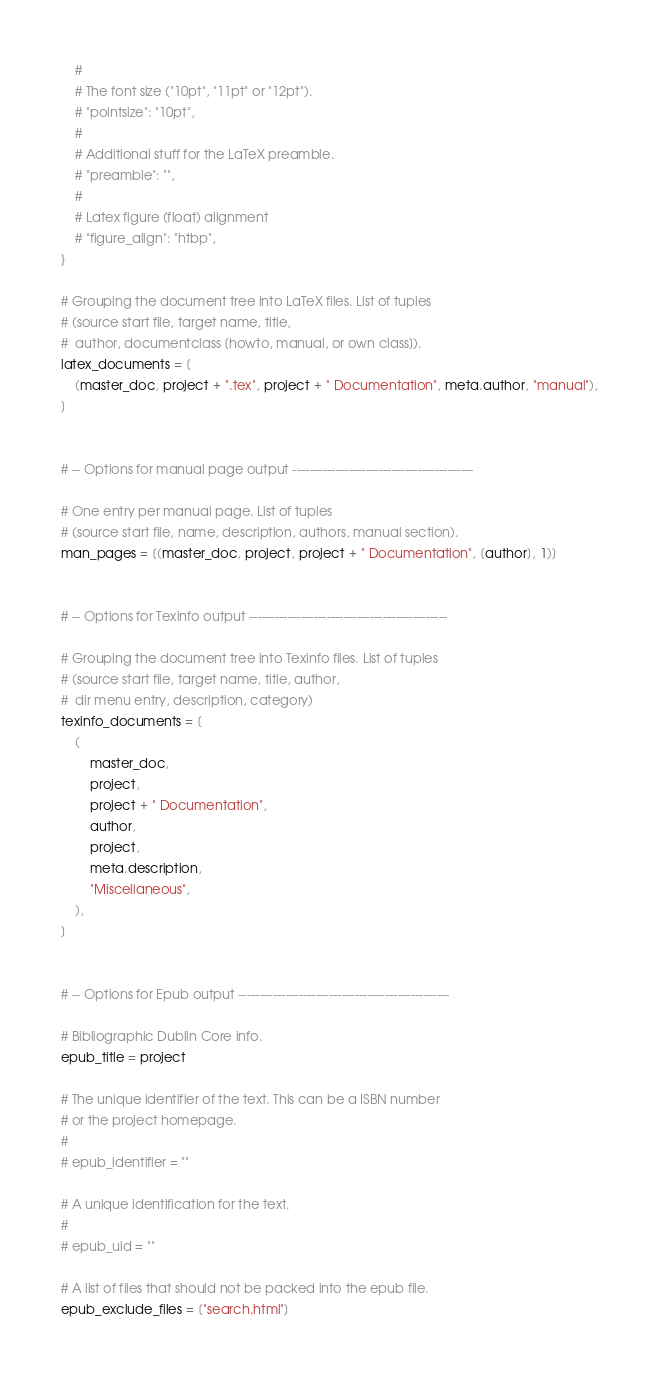Convert code to text. <code><loc_0><loc_0><loc_500><loc_500><_Python_>    #
    # The font size ("10pt", "11pt" or "12pt").
    # "pointsize": "10pt",
    #
    # Additional stuff for the LaTeX preamble.
    # "preamble": "",
    #
    # Latex figure (float) alignment
    # "figure_align": "htbp",
}

# Grouping the document tree into LaTeX files. List of tuples
# (source start file, target name, title,
#  author, documentclass [howto, manual, or own class]).
latex_documents = [
    (master_doc, project + ".tex", project + " Documentation", meta.author, "manual"),
]


# -- Options for manual page output ------------------------------------------

# One entry per manual page. List of tuples
# (source start file, name, description, authors, manual section).
man_pages = [(master_doc, project, project + " Documentation", [author], 1)]


# -- Options for Texinfo output ----------------------------------------------

# Grouping the document tree into Texinfo files. List of tuples
# (source start file, target name, title, author,
#  dir menu entry, description, category)
texinfo_documents = [
    (
        master_doc,
        project,
        project + " Documentation",
        author,
        project,
        meta.description,
        "Miscellaneous",
    ),
]


# -- Options for Epub output -------------------------------------------------

# Bibliographic Dublin Core info.
epub_title = project

# The unique identifier of the text. This can be a ISBN number
# or the project homepage.
#
# epub_identifier = ""

# A unique identification for the text.
#
# epub_uid = ""

# A list of files that should not be packed into the epub file.
epub_exclude_files = ["search.html"]
</code> 